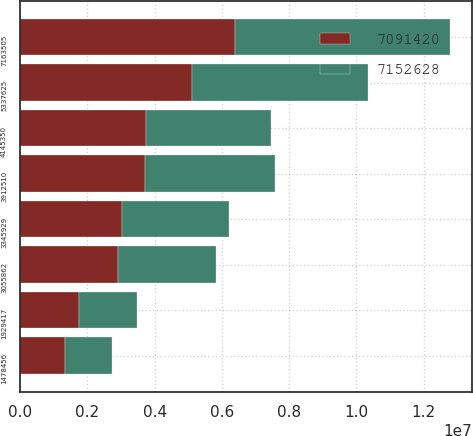Convert chart. <chart><loc_0><loc_0><loc_500><loc_500><stacked_bar_chart><ecel><fcel>7163505<fcel>5337625<fcel>4145350<fcel>3912510<fcel>3345929<fcel>3055862<fcel>1929417<fcel>1478456<nl><fcel>7.15263e+06<fcel>6.40582e+06<fcel>5.22031e+06<fcel>3.70941e+06<fcel>3.86249e+06<fcel>3.17995e+06<fcel>2.90643e+06<fcel>1.73995e+06<fcel>1.40838e+06<nl><fcel>7.09142e+06<fcel>6.39445e+06<fcel>5.12242e+06<fcel>3.75068e+06<fcel>3.70955e+06<fcel>3.01702e+06<fcel>2.91103e+06<fcel>1.74029e+06<fcel>1.3223e+06<nl></chart> 